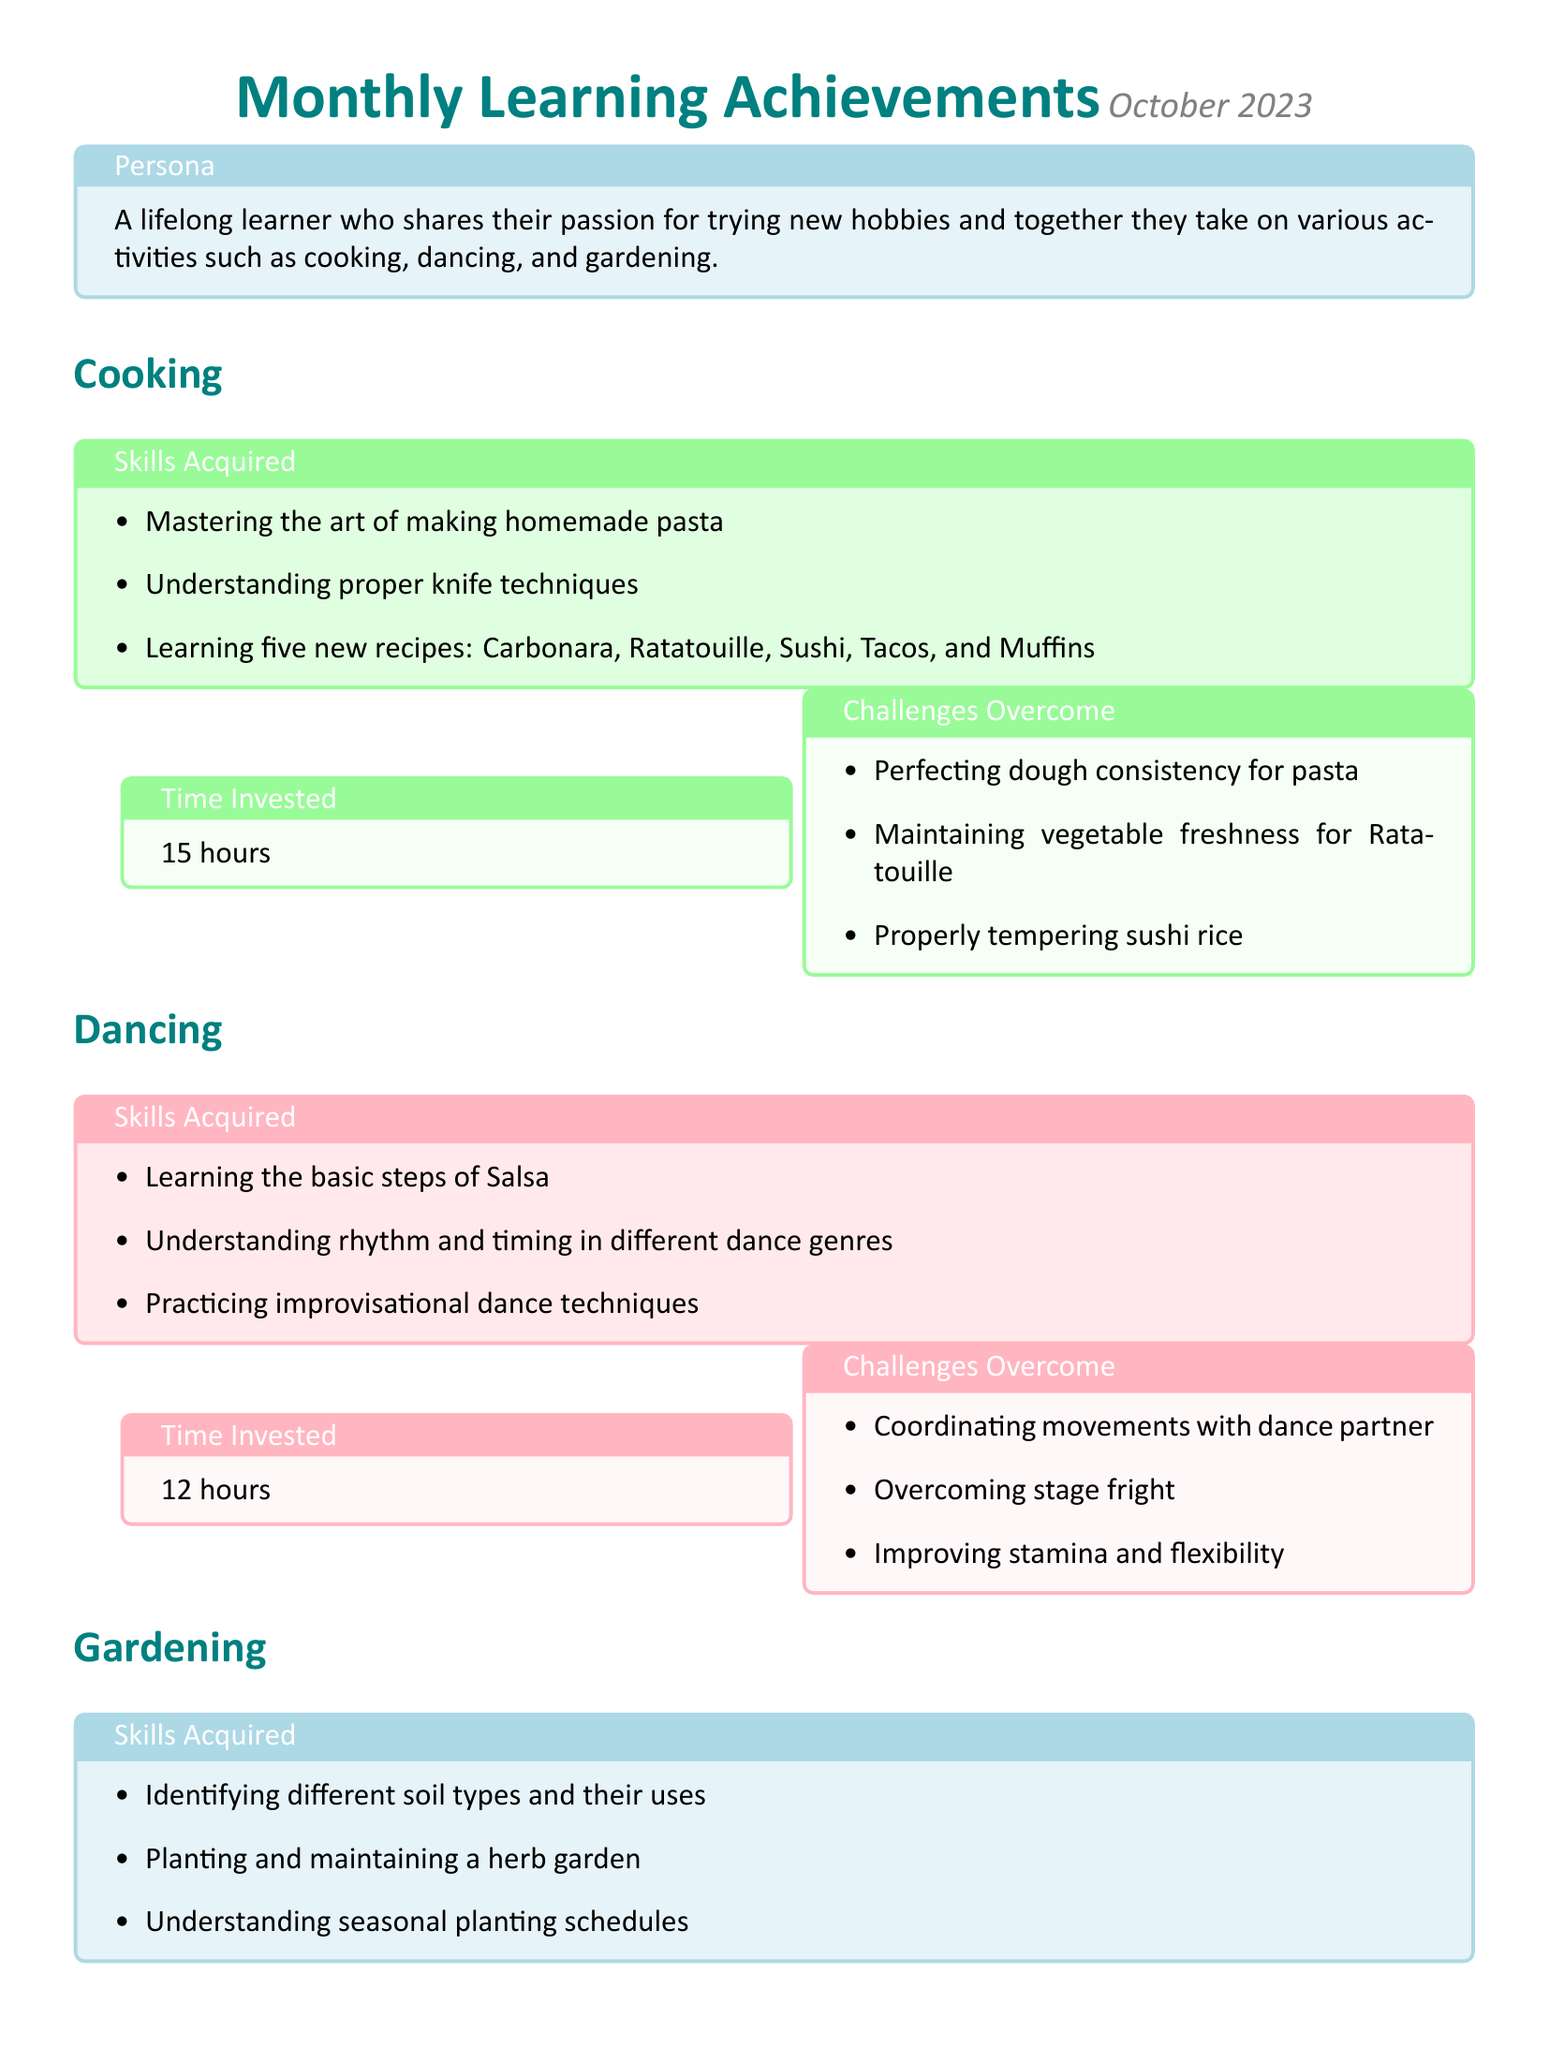What new recipes did you learn in cooking? The document lists five new recipes learned in cooking: Carbonara, Ratatouille, Sushi, Tacos, and Muffins.
Answer: Carbonara, Ratatouille, Sushi, Tacos, Muffins How many hours did you invest in dancing? The document states that a total of 12 hours were invested in dancing this month.
Answer: 12 hours What was the challenge faced in cooking related to pasta? The document mentions a challenge in cooking related to perfecting dough consistency for pasta.
Answer: Perfecting dough consistency for pasta What skills did you acquire in gardening? The document outlines skills such as identifying different soil types and planting a herb garden as skills acquired in gardening.
Answer: Identifying different soil types and planting a herb garden Which hobby had the least amount of time invested? By comparing time investments, gardening had the least amount of investment with 10 hours compared to others.
Answer: Gardening What did you learn about in dancing? The document states that basic steps of Salsa were one of the skills learned in dancing.
Answer: Basic steps of Salsa How much time was invested in cooking? The document lists that 15 hours were invested in cooking activities this month.
Answer: 15 hours Which challenges were faced when gardening? The document specifies three challenges in gardening, including addressing pest issues organically.
Answer: Addressing pest issues organically How many hours did you invest in gardening? The document indicates that a total of 10 hours were invested in gardening.
Answer: 10 hours 